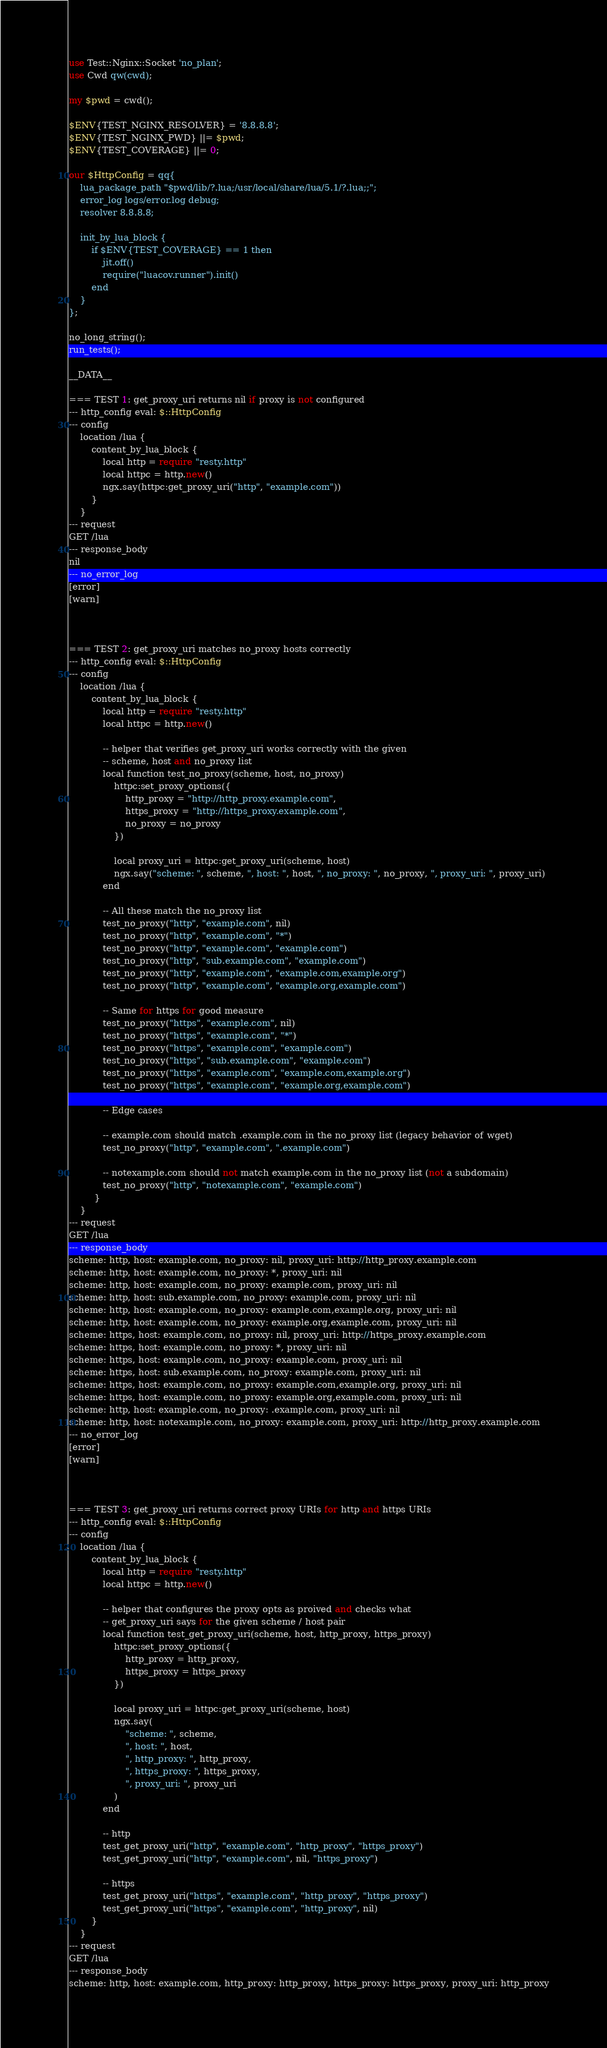<code> <loc_0><loc_0><loc_500><loc_500><_Perl_>use Test::Nginx::Socket 'no_plan';
use Cwd qw(cwd);

my $pwd = cwd();

$ENV{TEST_NGINX_RESOLVER} = '8.8.8.8';
$ENV{TEST_NGINX_PWD} ||= $pwd;
$ENV{TEST_COVERAGE} ||= 0;

our $HttpConfig = qq{
    lua_package_path "$pwd/lib/?.lua;/usr/local/share/lua/5.1/?.lua;;";
    error_log logs/error.log debug;
    resolver 8.8.8.8;

    init_by_lua_block {
        if $ENV{TEST_COVERAGE} == 1 then
            jit.off()
            require("luacov.runner").init()
        end
    }
};

no_long_string();
run_tests();

__DATA__

=== TEST 1: get_proxy_uri returns nil if proxy is not configured
--- http_config eval: $::HttpConfig
--- config
    location /lua {
        content_by_lua_block {
            local http = require "resty.http"
            local httpc = http.new()
            ngx.say(httpc:get_proxy_uri("http", "example.com"))
        }
    }
--- request
GET /lua
--- response_body
nil
--- no_error_log
[error]
[warn]



=== TEST 2: get_proxy_uri matches no_proxy hosts correctly
--- http_config eval: $::HttpConfig
--- config
    location /lua {
        content_by_lua_block {
            local http = require "resty.http"
            local httpc = http.new()

            -- helper that verifies get_proxy_uri works correctly with the given
            -- scheme, host and no_proxy list
            local function test_no_proxy(scheme, host, no_proxy)
                httpc:set_proxy_options({
                    http_proxy = "http://http_proxy.example.com",
                    https_proxy = "http://https_proxy.example.com",
                    no_proxy = no_proxy
                })

                local proxy_uri = httpc:get_proxy_uri(scheme, host)
                ngx.say("scheme: ", scheme, ", host: ", host, ", no_proxy: ", no_proxy, ", proxy_uri: ", proxy_uri)
            end

            -- All these match the no_proxy list
            test_no_proxy("http", "example.com", nil)
            test_no_proxy("http", "example.com", "*")
            test_no_proxy("http", "example.com", "example.com")
            test_no_proxy("http", "sub.example.com", "example.com")
            test_no_proxy("http", "example.com", "example.com,example.org")
            test_no_proxy("http", "example.com", "example.org,example.com")

            -- Same for https for good measure
            test_no_proxy("https", "example.com", nil)
            test_no_proxy("https", "example.com", "*")
            test_no_proxy("https", "example.com", "example.com")
            test_no_proxy("https", "sub.example.com", "example.com")
            test_no_proxy("https", "example.com", "example.com,example.org")
            test_no_proxy("https", "example.com", "example.org,example.com")

            -- Edge cases

            -- example.com should match .example.com in the no_proxy list (legacy behavior of wget)
            test_no_proxy("http", "example.com", ".example.com")

            -- notexample.com should not match example.com in the no_proxy list (not a subdomain)
            test_no_proxy("http", "notexample.com", "example.com")
         }
    }
--- request
GET /lua
--- response_body
scheme: http, host: example.com, no_proxy: nil, proxy_uri: http://http_proxy.example.com
scheme: http, host: example.com, no_proxy: *, proxy_uri: nil
scheme: http, host: example.com, no_proxy: example.com, proxy_uri: nil
scheme: http, host: sub.example.com, no_proxy: example.com, proxy_uri: nil
scheme: http, host: example.com, no_proxy: example.com,example.org, proxy_uri: nil
scheme: http, host: example.com, no_proxy: example.org,example.com, proxy_uri: nil
scheme: https, host: example.com, no_proxy: nil, proxy_uri: http://https_proxy.example.com
scheme: https, host: example.com, no_proxy: *, proxy_uri: nil
scheme: https, host: example.com, no_proxy: example.com, proxy_uri: nil
scheme: https, host: sub.example.com, no_proxy: example.com, proxy_uri: nil
scheme: https, host: example.com, no_proxy: example.com,example.org, proxy_uri: nil
scheme: https, host: example.com, no_proxy: example.org,example.com, proxy_uri: nil
scheme: http, host: example.com, no_proxy: .example.com, proxy_uri: nil
scheme: http, host: notexample.com, no_proxy: example.com, proxy_uri: http://http_proxy.example.com
--- no_error_log
[error]
[warn]



=== TEST 3: get_proxy_uri returns correct proxy URIs for http and https URIs
--- http_config eval: $::HttpConfig
--- config
    location /lua {
        content_by_lua_block {
            local http = require "resty.http"
            local httpc = http.new()

            -- helper that configures the proxy opts as proived and checks what
            -- get_proxy_uri says for the given scheme / host pair
            local function test_get_proxy_uri(scheme, host, http_proxy, https_proxy)
                httpc:set_proxy_options({
                    http_proxy = http_proxy,
                    https_proxy = https_proxy
                })

                local proxy_uri = httpc:get_proxy_uri(scheme, host)
                ngx.say(
                    "scheme: ", scheme,
                    ", host: ", host,
                    ", http_proxy: ", http_proxy,
                    ", https_proxy: ", https_proxy,
                    ", proxy_uri: ", proxy_uri
                )
            end

            -- http
            test_get_proxy_uri("http", "example.com", "http_proxy", "https_proxy")
            test_get_proxy_uri("http", "example.com", nil, "https_proxy")

            -- https
            test_get_proxy_uri("https", "example.com", "http_proxy", "https_proxy")
            test_get_proxy_uri("https", "example.com", "http_proxy", nil)
        }
    }
--- request
GET /lua
--- response_body
scheme: http, host: example.com, http_proxy: http_proxy, https_proxy: https_proxy, proxy_uri: http_proxy</code> 